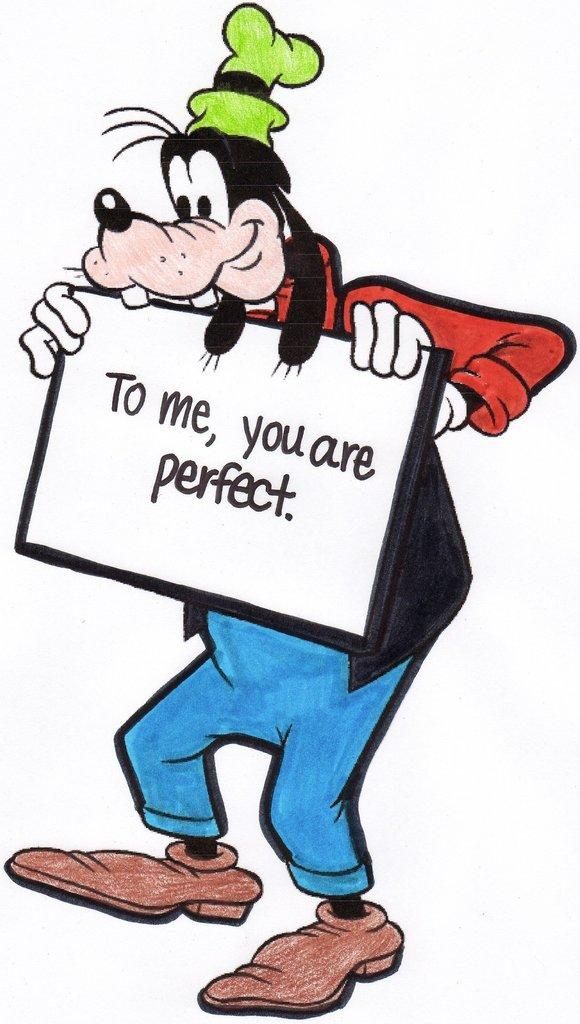What is the main subject in the middle of the image? There is a cartoon image in the middle of the image. What else can be seen in the image besides the cartoon? There is text visible in the image. How many beans are present in the image? There are no beans visible in the image. What type of toothbrush is shown in the image? There is no toothbrush present in the image. 